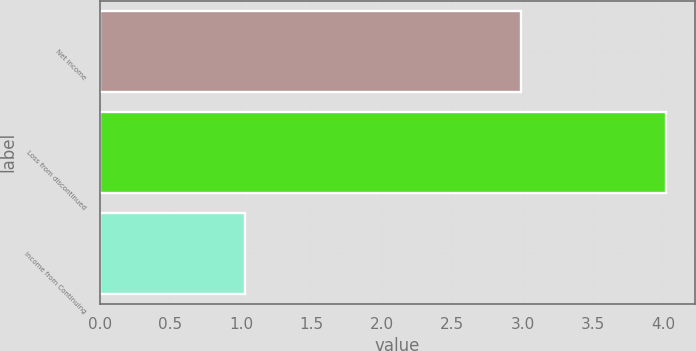Convert chart. <chart><loc_0><loc_0><loc_500><loc_500><bar_chart><fcel>Net income<fcel>Loss from discontinued<fcel>Income from Continuing<nl><fcel>2.99<fcel>4.02<fcel>1.03<nl></chart> 